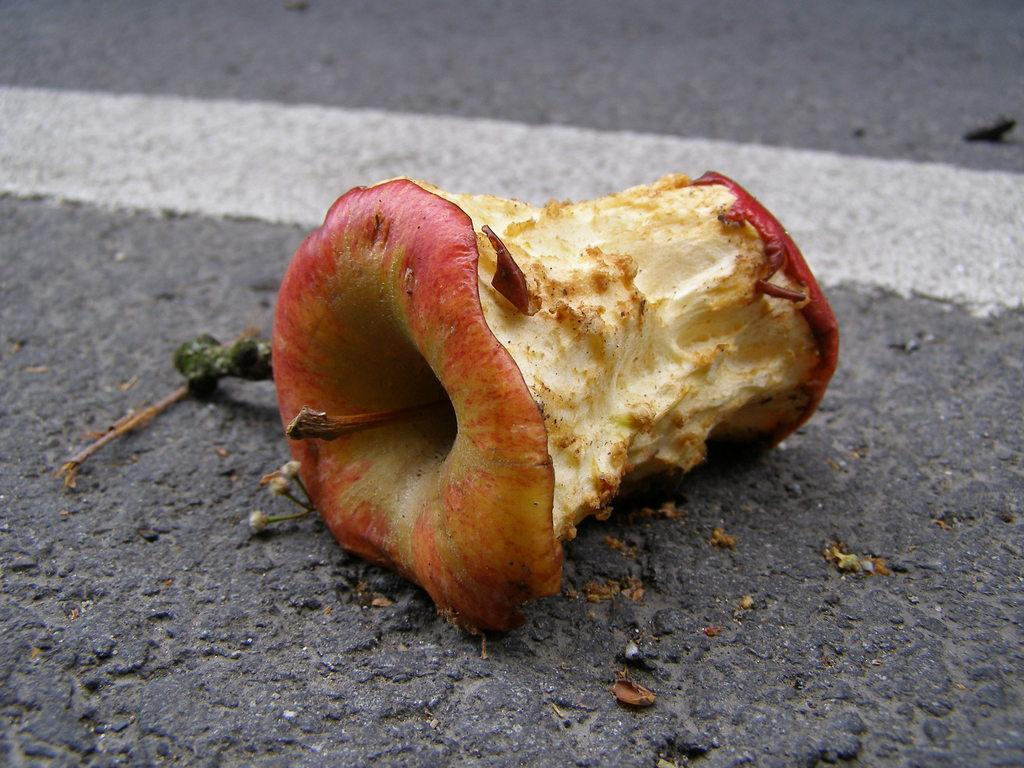What is the main subject in the center of the image? There is a bitten apple in the center of the image. What can be seen in the background of the image? There is a road visible in the background of the image. How many boats are visible in the image? There are no boats present in the image; it features a bitten apple and a road in the background. What type of stitch is used to create the apple in the image? The image is a photograph, not a drawing or painting, so there is no stitching involved in creating the apple. 